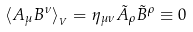Convert formula to latex. <formula><loc_0><loc_0><loc_500><loc_500>\langle A _ { \mu } B ^ { \nu } \rangle _ { _ { V } } = \eta _ { \mu \nu } \tilde { A } _ { \rho } \tilde { B } ^ { \rho } \equiv 0</formula> 